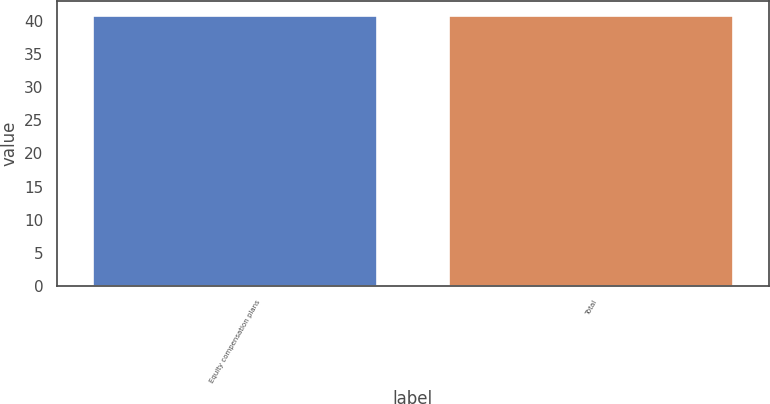Convert chart. <chart><loc_0><loc_0><loc_500><loc_500><bar_chart><fcel>Equity compensation plans<fcel>Total<nl><fcel>40.85<fcel>40.95<nl></chart> 